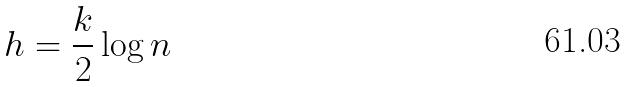Convert formula to latex. <formula><loc_0><loc_0><loc_500><loc_500>h = \frac { k } { 2 } \log n</formula> 